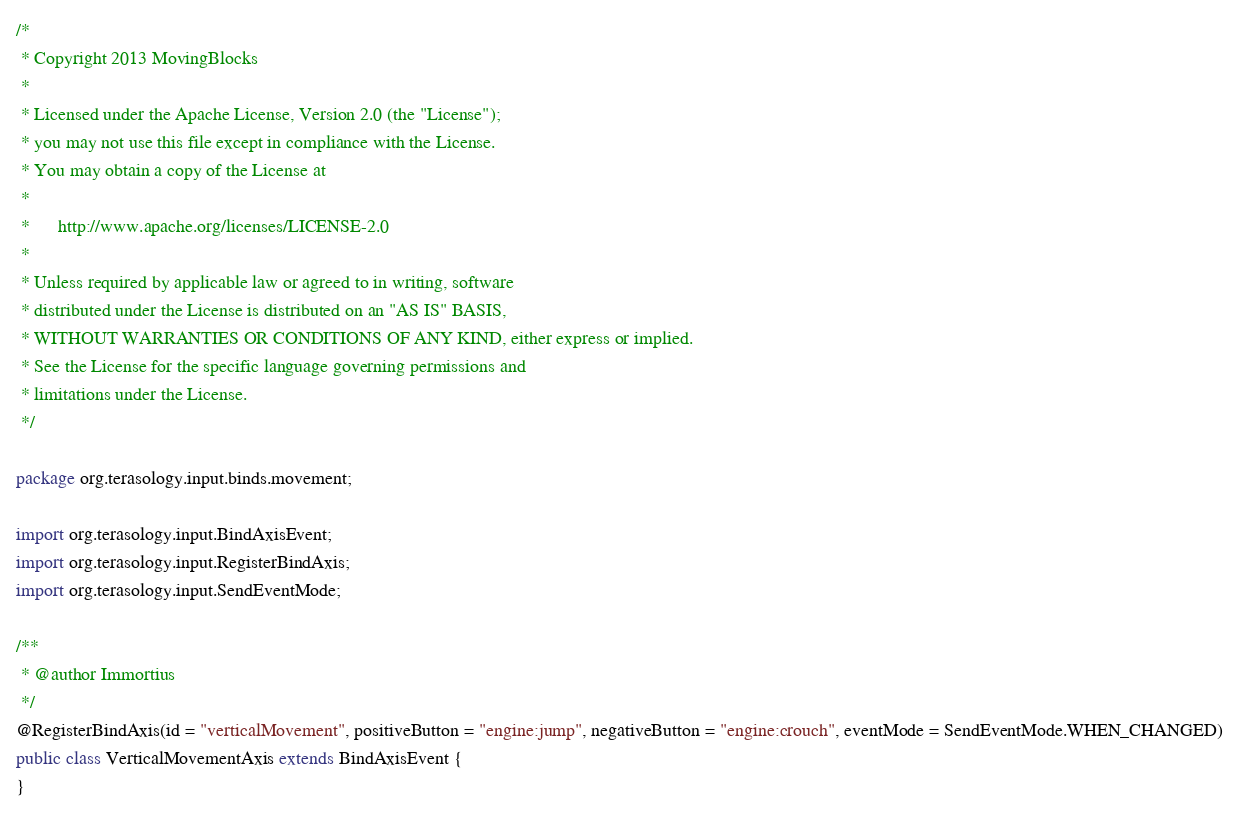<code> <loc_0><loc_0><loc_500><loc_500><_Java_>/*
 * Copyright 2013 MovingBlocks
 *
 * Licensed under the Apache License, Version 2.0 (the "License");
 * you may not use this file except in compliance with the License.
 * You may obtain a copy of the License at
 *
 *      http://www.apache.org/licenses/LICENSE-2.0
 *
 * Unless required by applicable law or agreed to in writing, software
 * distributed under the License is distributed on an "AS IS" BASIS,
 * WITHOUT WARRANTIES OR CONDITIONS OF ANY KIND, either express or implied.
 * See the License for the specific language governing permissions and
 * limitations under the License.
 */

package org.terasology.input.binds.movement;

import org.terasology.input.BindAxisEvent;
import org.terasology.input.RegisterBindAxis;
import org.terasology.input.SendEventMode;

/**
 * @author Immortius
 */
@RegisterBindAxis(id = "verticalMovement", positiveButton = "engine:jump", negativeButton = "engine:crouch", eventMode = SendEventMode.WHEN_CHANGED)
public class VerticalMovementAxis extends BindAxisEvent {
}
</code> 